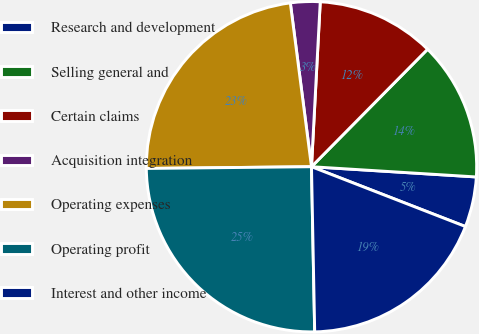Convert chart. <chart><loc_0><loc_0><loc_500><loc_500><pie_chart><fcel>Research and development<fcel>Selling general and<fcel>Certain claims<fcel>Acquisition integration<fcel>Operating expenses<fcel>Operating profit<fcel>Interest and other income<nl><fcel>4.91%<fcel>13.58%<fcel>11.56%<fcel>2.89%<fcel>23.12%<fcel>25.14%<fcel>18.79%<nl></chart> 